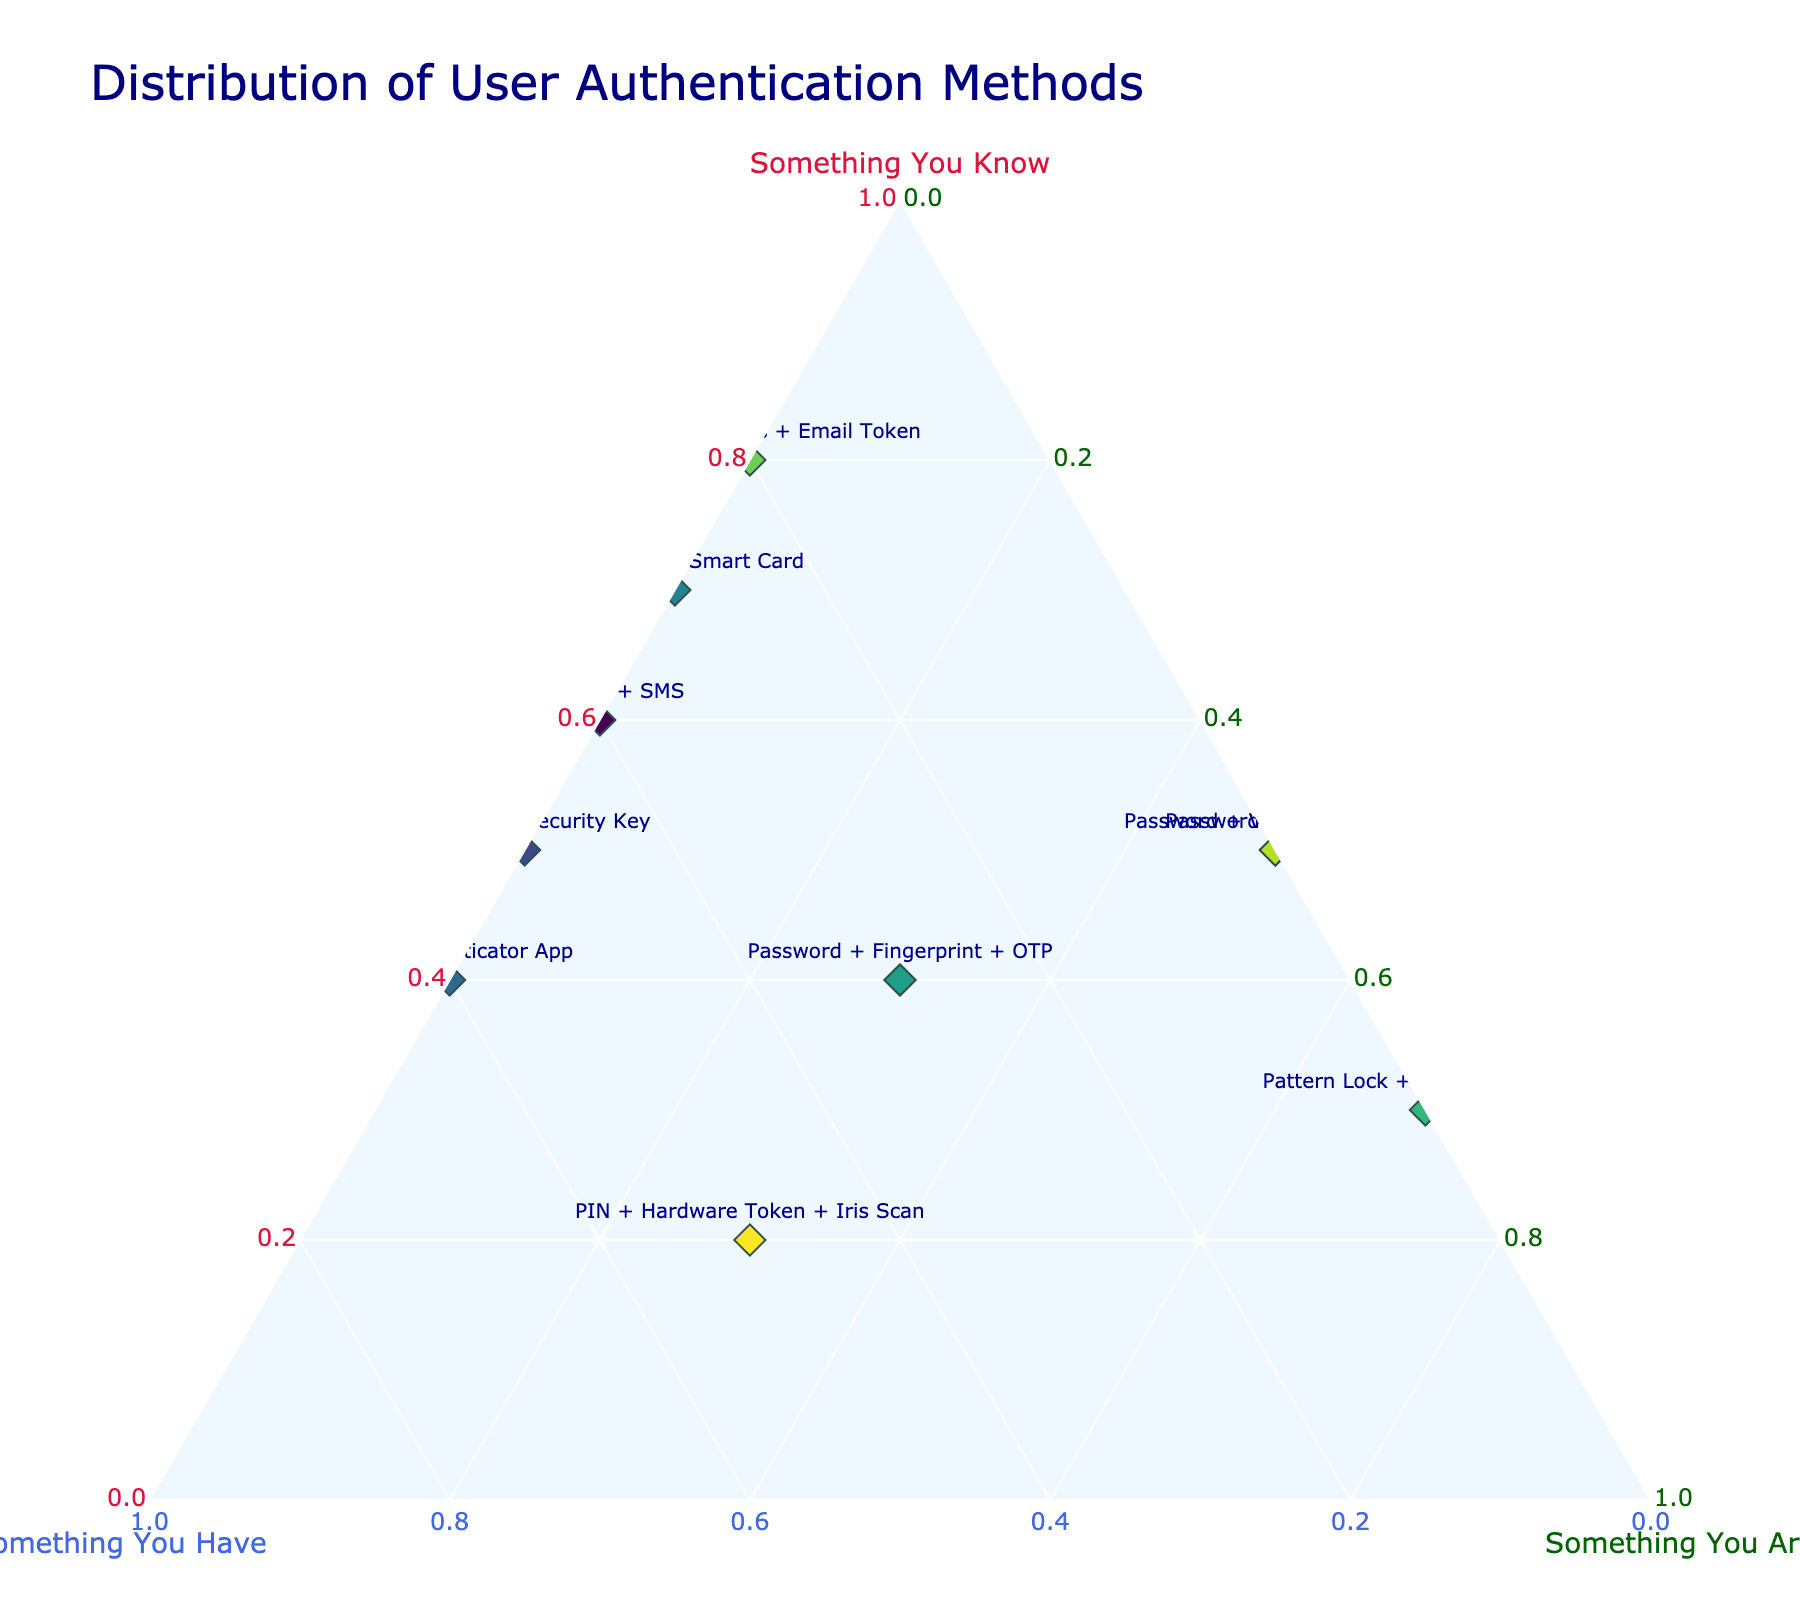What's the title of the figure? The title of the figure is displayed at the top and summarizes the content of the plot.
Answer: Distribution of User Authentication Methods How many different methods are represented in the plot? Each method is represented as a separate point in the plot. By counting the points, we can identify the total number of methods.
Answer: 10 Which authentication method relies most heavily on "Something You Are"? Look for the method with the highest value on the "Something You Are" (c-axis).
Answer: Pattern Lock + Face Recognition What is the authentication method with the highest value on the "Something You Have" axis? Identify the method positioned highest on the "Something You Have" (b-axis).
Answer: PIN + Authenticator App What is the combined value of "Something You Know" and "Something You Have" for Password + Security Key? Add the values of "Something You Know" and "Something You Have" for the specified method.
Answer: 1.0 Which method has equal reliance on both "Something You Know" and "Something You Are"? Find the data point where the values of "Something You Know" and "Something You Are" are equal.
Answer: Password + Biometric Compare Password + SMS and Password + Fingerprint + OTP based on their reliance on "Something You Know". Which method relies more on "Something You Know"? Check the values of "Something You Know" for both methods and compare them.
Answer: Password + SMS What is the centroid of the cluster formed by Password + SMS, Password + Security Key, and Password + Biometric on the ternary plot? Calculate the average values of "Something You Know", "Something You Have", and "Something You Are" for these three methods to determine the centroid.
Answer: (0.53, 0.3, 0.33 - approximate values) Which method has the lowest combined reliance on "Something You Know" and "Something You Have"? Add the values of "Something You Know" and "Something You Have" for each method and identify the one with the lowest total.
Answer: Pattern Lock + Face Recognition What is the total reliance on "Something You Are" for all the methods combined? Sum the "Something You Are" values for all the methods to find the total.
Answer: 3.3 